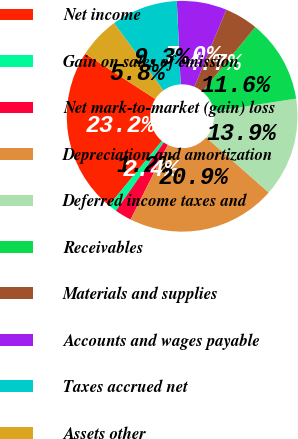Convert chart to OTSL. <chart><loc_0><loc_0><loc_500><loc_500><pie_chart><fcel>Net income<fcel>Gain on sales of emission<fcel>Net mark-to-market (gain) loss<fcel>Depreciation and amortization<fcel>Deferred income taxes and<fcel>Receivables<fcel>Materials and supplies<fcel>Accounts and wages payable<fcel>Taxes accrued net<fcel>Assets other<nl><fcel>23.2%<fcel>1.2%<fcel>2.36%<fcel>20.88%<fcel>13.94%<fcel>11.62%<fcel>4.68%<fcel>6.99%<fcel>9.31%<fcel>5.83%<nl></chart> 